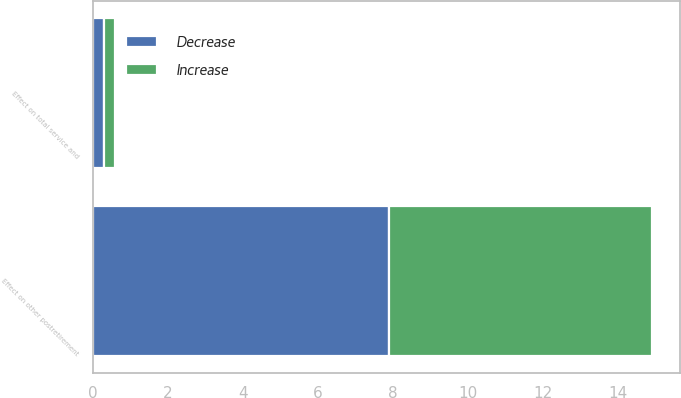<chart> <loc_0><loc_0><loc_500><loc_500><stacked_bar_chart><ecel><fcel>Effect on other postretirement<fcel>Effect on total service and<nl><fcel>Decrease<fcel>7.9<fcel>0.3<nl><fcel>Increase<fcel>7<fcel>0.3<nl></chart> 